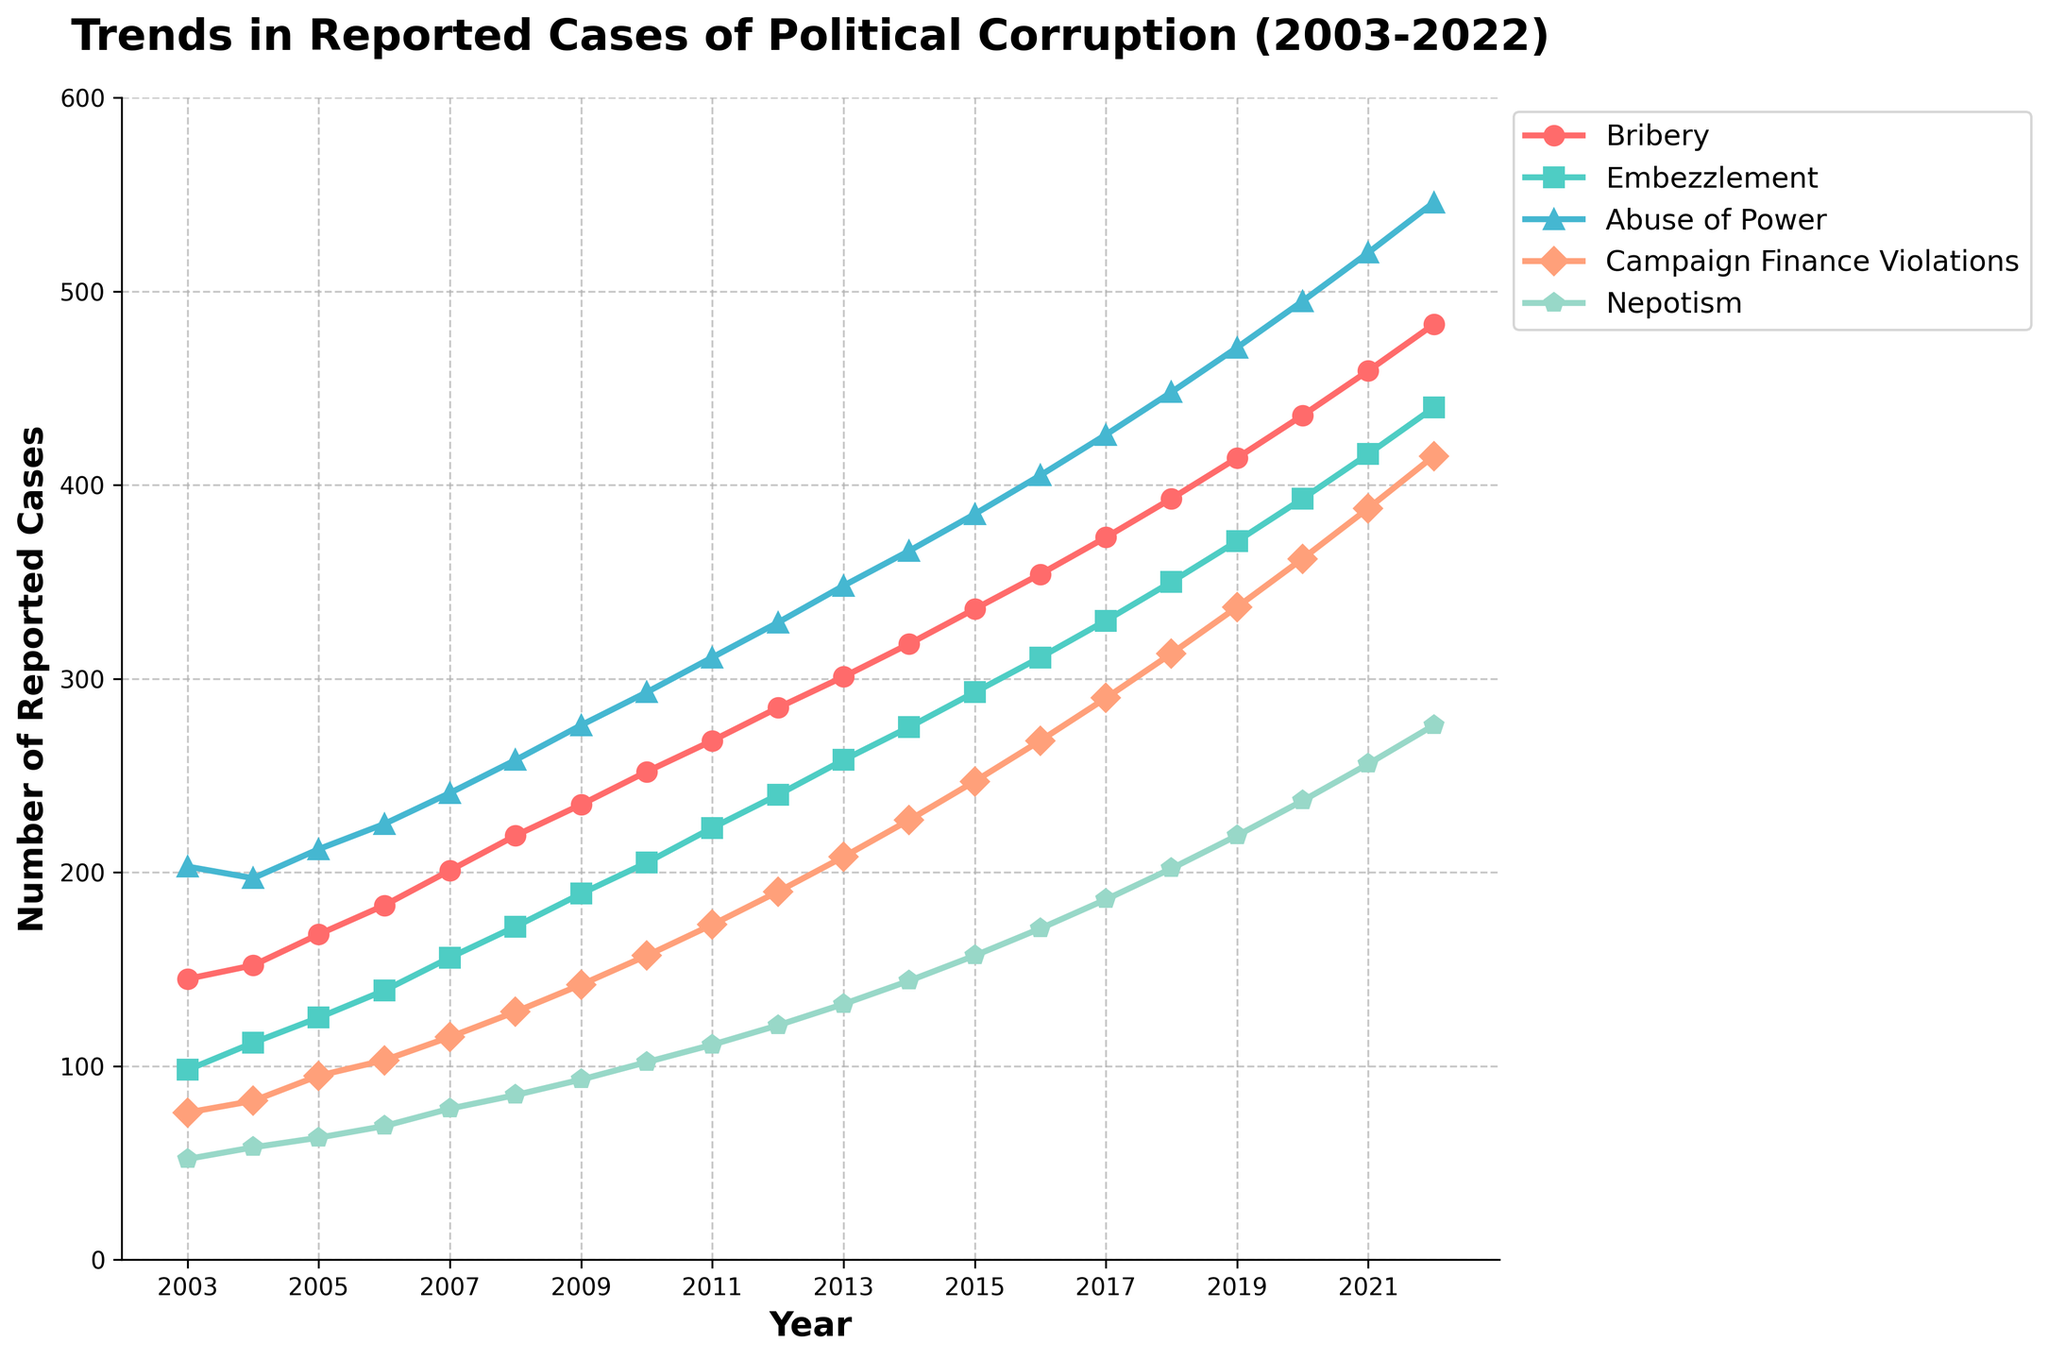How many total reported cases of political corruption were there in 2022? Sum the reported cases across all categories for the year 2022: Bribery (483), Embezzlement (440), Abuse of Power (546), Campaign Finance Violations (415), Nepotism (276). Total = 483 + 440 + 546 + 415 + 276 = 2160.
Answer: 2160 Which type of offense has shown the highest increase in reported cases from 2003 to 2022? Calculate the difference in reported cases for each type of offense from 2003 to 2022 and identify the largest value. Bribery: 483-145=338, Embezzlement: 440-98=342, Abuse of Power: 546-203=343, Campaign Finance Violations: 415-76=339, Nepotism: 276-52=224. The largest increase is for Abuse of Power by 343.
Answer: Abuse of Power In which year did Campaign Finance Violations first exceed 200 cases? Examine the data points for Campaign Finance Violations across the years and find the first instance it surpasses 200 cases. From the plot, it crosses 200 in 2013 with 208 cases.
Answer: 2013 Between what years did Nepotism see the fastest growth in reported cases? Look for the period with the steepest slope for Nepotism. From the plot, the increase from 2018 (202) to 2020 (237) seems to be the fastest, a rise of 35 cases in 2 years.
Answer: 2018-2020 By how much did the reported cases of Embezzlement increase between 2008 and 2015? Determine the values for Embezzlement in 2008 (172) and 2015 (293) and find their difference. Increase = 293 - 172 = 121 cases.
Answer: 121 Which offense showed the most constant rate of increase over the years? Analyze the trends for a consistent, non-erratic increase across the chart. Bribery shows a steady and linear climb from 2003 to 2022.
Answer: Bribery How many more reported cases of Abuse of Power were there in 2022 compared to 2003? Subtract the number of cases in 2003 from the number in 2022 for Abuse of Power: 546 - 203 = 343.
Answer: 343 What is the average annual increase in reported cases of Bribery from 2003 to 2022? Calculate the total increase and divide it by the number of years (2022-2003=19 years). Increase = 483 - 145 = 338. Average annual increase = 338 / 19 ≈ 17.8.
Answer: 17.8 Which offense had the highest variability in reported cases over the 20-year period? By visually comparing the fluctuation of all offense lines, we observe that Abuse of Power shows the highest variability as the line is the steepest and has the highest final value.
Answer: Abuse of Power 